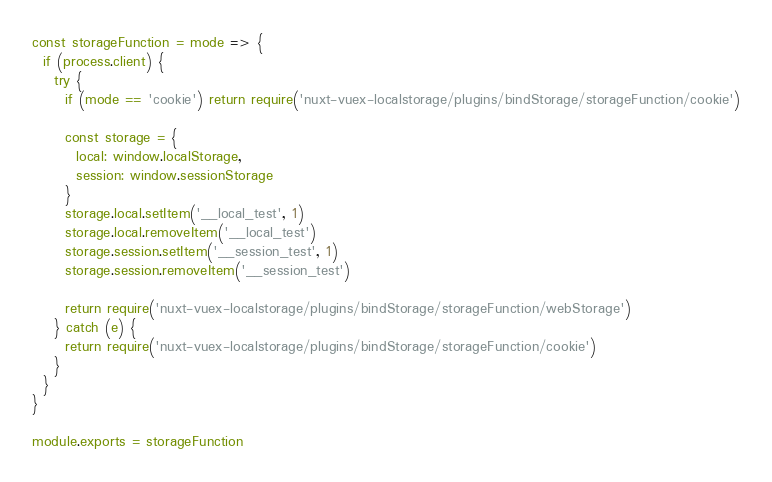<code> <loc_0><loc_0><loc_500><loc_500><_JavaScript_>const storageFunction = mode => {
  if (process.client) {
    try {
      if (mode == 'cookie') return require('nuxt-vuex-localstorage/plugins/bindStorage/storageFunction/cookie')

      const storage = {
        local: window.localStorage,
        session: window.sessionStorage
      }
      storage.local.setItem('__local_test', 1)
      storage.local.removeItem('__local_test')
      storage.session.setItem('__session_test', 1)
      storage.session.removeItem('__session_test')

      return require('nuxt-vuex-localstorage/plugins/bindStorage/storageFunction/webStorage')
    } catch (e) {
      return require('nuxt-vuex-localstorage/plugins/bindStorage/storageFunction/cookie')
    }
  }
}

module.exports = storageFunction
</code> 